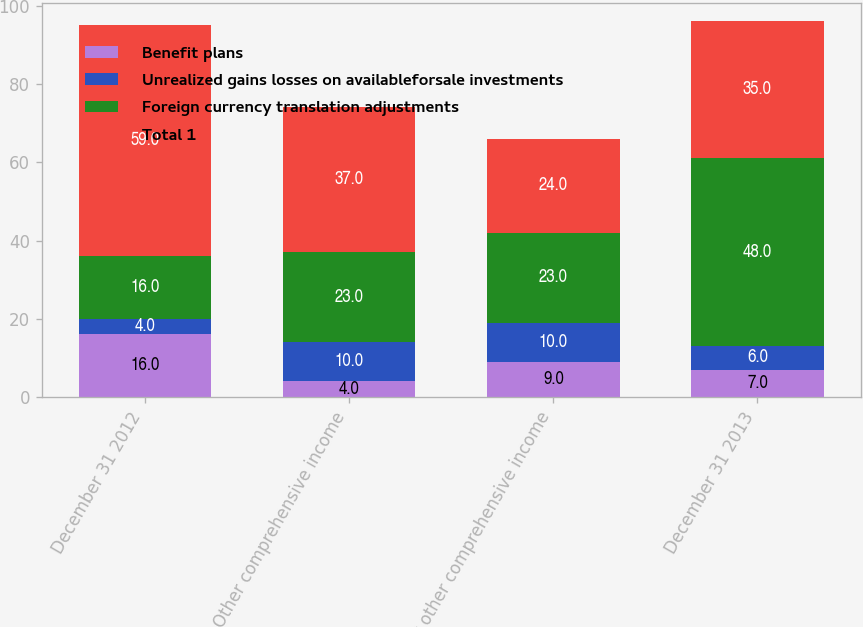Convert chart. <chart><loc_0><loc_0><loc_500><loc_500><stacked_bar_chart><ecel><fcel>December 31 2012<fcel>Other comprehensive income<fcel>Net other comprehensive income<fcel>December 31 2013<nl><fcel>Benefit plans<fcel>16<fcel>4<fcel>9<fcel>7<nl><fcel>Unrealized gains losses on availableforsale investments<fcel>4<fcel>10<fcel>10<fcel>6<nl><fcel>Foreign currency translation adjustments<fcel>16<fcel>23<fcel>23<fcel>48<nl><fcel>Total 1<fcel>59<fcel>37<fcel>24<fcel>35<nl></chart> 